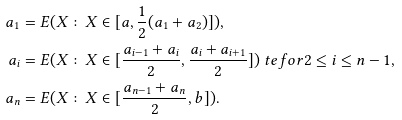Convert formula to latex. <formula><loc_0><loc_0><loc_500><loc_500>a _ { 1 } & = E ( X \colon X \in [ a , \frac { 1 } { 2 } ( a _ { 1 } + a _ { 2 } ) ] ) , \\ a _ { i } & = E ( X \colon X \in [ \frac { a _ { i - 1 } + a _ { i } } { 2 } , \frac { a _ { i } + a _ { i + 1 } } { 2 } ] ) \ t e { f o r } 2 \leq i \leq n - 1 , \\ a _ { n } & = E ( X \colon X \in [ \frac { a _ { n - 1 } + a _ { n } } { 2 } , b ] ) .</formula> 